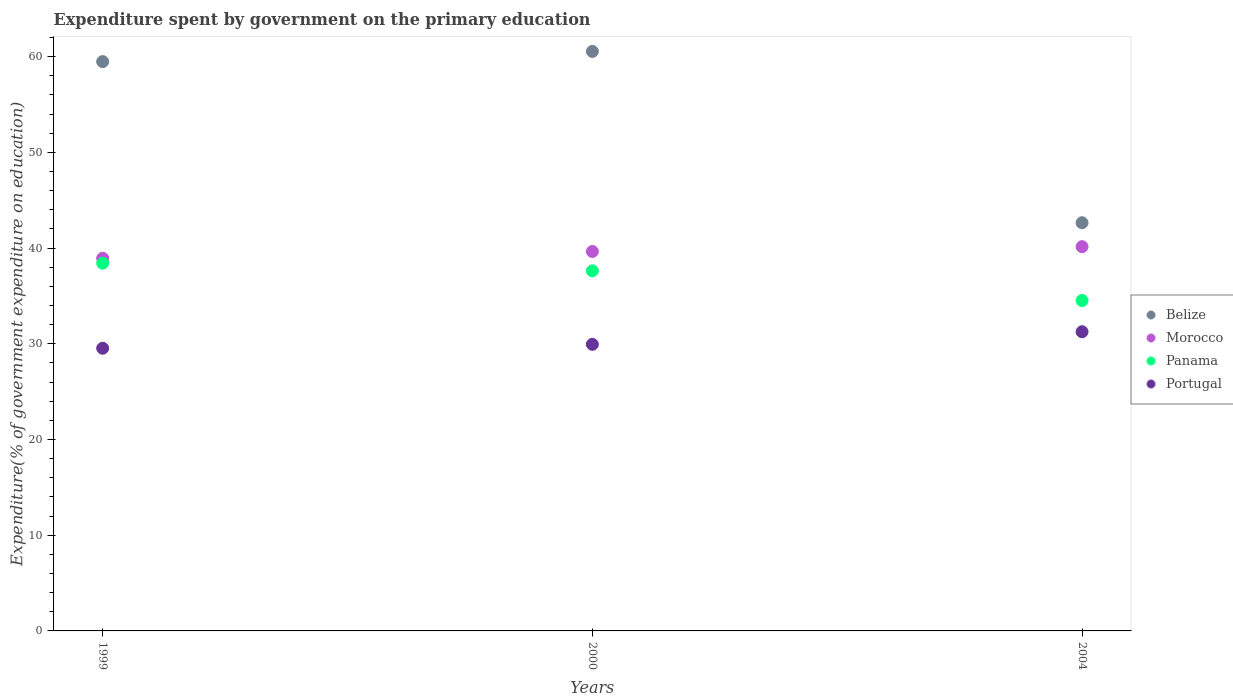How many different coloured dotlines are there?
Give a very brief answer. 4. Is the number of dotlines equal to the number of legend labels?
Make the answer very short. Yes. What is the expenditure spent by government on the primary education in Belize in 2004?
Keep it short and to the point. 42.65. Across all years, what is the maximum expenditure spent by government on the primary education in Portugal?
Give a very brief answer. 31.26. Across all years, what is the minimum expenditure spent by government on the primary education in Belize?
Offer a terse response. 42.65. What is the total expenditure spent by government on the primary education in Morocco in the graph?
Provide a succinct answer. 118.72. What is the difference between the expenditure spent by government on the primary education in Portugal in 1999 and that in 2004?
Your answer should be very brief. -1.72. What is the difference between the expenditure spent by government on the primary education in Panama in 1999 and the expenditure spent by government on the primary education in Belize in 2000?
Your answer should be very brief. -22.13. What is the average expenditure spent by government on the primary education in Panama per year?
Provide a short and direct response. 36.85. In the year 2000, what is the difference between the expenditure spent by government on the primary education in Morocco and expenditure spent by government on the primary education in Belize?
Your answer should be very brief. -20.9. In how many years, is the expenditure spent by government on the primary education in Portugal greater than 38 %?
Keep it short and to the point. 0. What is the ratio of the expenditure spent by government on the primary education in Belize in 1999 to that in 2000?
Keep it short and to the point. 0.98. Is the difference between the expenditure spent by government on the primary education in Morocco in 1999 and 2004 greater than the difference between the expenditure spent by government on the primary education in Belize in 1999 and 2004?
Give a very brief answer. No. What is the difference between the highest and the second highest expenditure spent by government on the primary education in Belize?
Your answer should be very brief. 1.07. What is the difference between the highest and the lowest expenditure spent by government on the primary education in Belize?
Your answer should be very brief. 17.9. In how many years, is the expenditure spent by government on the primary education in Panama greater than the average expenditure spent by government on the primary education in Panama taken over all years?
Make the answer very short. 2. Is the sum of the expenditure spent by government on the primary education in Belize in 1999 and 2004 greater than the maximum expenditure spent by government on the primary education in Morocco across all years?
Offer a very short reply. Yes. Is it the case that in every year, the sum of the expenditure spent by government on the primary education in Panama and expenditure spent by government on the primary education in Morocco  is greater than the sum of expenditure spent by government on the primary education in Belize and expenditure spent by government on the primary education in Portugal?
Keep it short and to the point. No. Is it the case that in every year, the sum of the expenditure spent by government on the primary education in Panama and expenditure spent by government on the primary education in Portugal  is greater than the expenditure spent by government on the primary education in Morocco?
Make the answer very short. Yes. Is the expenditure spent by government on the primary education in Panama strictly less than the expenditure spent by government on the primary education in Belize over the years?
Make the answer very short. Yes. How many years are there in the graph?
Your answer should be compact. 3. What is the difference between two consecutive major ticks on the Y-axis?
Offer a terse response. 10. Does the graph contain any zero values?
Your answer should be very brief. No. How are the legend labels stacked?
Make the answer very short. Vertical. What is the title of the graph?
Provide a succinct answer. Expenditure spent by government on the primary education. Does "Cameroon" appear as one of the legend labels in the graph?
Make the answer very short. No. What is the label or title of the X-axis?
Your answer should be very brief. Years. What is the label or title of the Y-axis?
Ensure brevity in your answer.  Expenditure(% of government expenditure on education). What is the Expenditure(% of government expenditure on education) of Belize in 1999?
Your answer should be compact. 59.48. What is the Expenditure(% of government expenditure on education) in Morocco in 1999?
Your answer should be compact. 38.93. What is the Expenditure(% of government expenditure on education) of Panama in 1999?
Provide a short and direct response. 38.42. What is the Expenditure(% of government expenditure on education) of Portugal in 1999?
Offer a very short reply. 29.53. What is the Expenditure(% of government expenditure on education) in Belize in 2000?
Give a very brief answer. 60.54. What is the Expenditure(% of government expenditure on education) of Morocco in 2000?
Keep it short and to the point. 39.64. What is the Expenditure(% of government expenditure on education) in Panama in 2000?
Provide a short and direct response. 37.62. What is the Expenditure(% of government expenditure on education) in Portugal in 2000?
Offer a very short reply. 29.94. What is the Expenditure(% of government expenditure on education) in Belize in 2004?
Your answer should be compact. 42.65. What is the Expenditure(% of government expenditure on education) in Morocco in 2004?
Offer a terse response. 40.15. What is the Expenditure(% of government expenditure on education) of Panama in 2004?
Provide a succinct answer. 34.52. What is the Expenditure(% of government expenditure on education) in Portugal in 2004?
Ensure brevity in your answer.  31.26. Across all years, what is the maximum Expenditure(% of government expenditure on education) in Belize?
Your answer should be compact. 60.54. Across all years, what is the maximum Expenditure(% of government expenditure on education) in Morocco?
Your answer should be very brief. 40.15. Across all years, what is the maximum Expenditure(% of government expenditure on education) in Panama?
Give a very brief answer. 38.42. Across all years, what is the maximum Expenditure(% of government expenditure on education) of Portugal?
Your answer should be very brief. 31.26. Across all years, what is the minimum Expenditure(% of government expenditure on education) of Belize?
Your response must be concise. 42.65. Across all years, what is the minimum Expenditure(% of government expenditure on education) in Morocco?
Give a very brief answer. 38.93. Across all years, what is the minimum Expenditure(% of government expenditure on education) in Panama?
Offer a very short reply. 34.52. Across all years, what is the minimum Expenditure(% of government expenditure on education) in Portugal?
Offer a very short reply. 29.53. What is the total Expenditure(% of government expenditure on education) in Belize in the graph?
Give a very brief answer. 162.67. What is the total Expenditure(% of government expenditure on education) of Morocco in the graph?
Your response must be concise. 118.72. What is the total Expenditure(% of government expenditure on education) of Panama in the graph?
Provide a succinct answer. 110.56. What is the total Expenditure(% of government expenditure on education) of Portugal in the graph?
Your answer should be compact. 90.73. What is the difference between the Expenditure(% of government expenditure on education) of Belize in 1999 and that in 2000?
Your response must be concise. -1.07. What is the difference between the Expenditure(% of government expenditure on education) in Morocco in 1999 and that in 2000?
Offer a very short reply. -0.71. What is the difference between the Expenditure(% of government expenditure on education) of Panama in 1999 and that in 2000?
Offer a terse response. 0.8. What is the difference between the Expenditure(% of government expenditure on education) in Portugal in 1999 and that in 2000?
Offer a terse response. -0.41. What is the difference between the Expenditure(% of government expenditure on education) in Belize in 1999 and that in 2004?
Your response must be concise. 16.83. What is the difference between the Expenditure(% of government expenditure on education) of Morocco in 1999 and that in 2004?
Your answer should be compact. -1.21. What is the difference between the Expenditure(% of government expenditure on education) in Panama in 1999 and that in 2004?
Make the answer very short. 3.9. What is the difference between the Expenditure(% of government expenditure on education) in Portugal in 1999 and that in 2004?
Offer a terse response. -1.72. What is the difference between the Expenditure(% of government expenditure on education) in Belize in 2000 and that in 2004?
Keep it short and to the point. 17.9. What is the difference between the Expenditure(% of government expenditure on education) of Morocco in 2000 and that in 2004?
Your answer should be very brief. -0.5. What is the difference between the Expenditure(% of government expenditure on education) of Panama in 2000 and that in 2004?
Provide a succinct answer. 3.1. What is the difference between the Expenditure(% of government expenditure on education) of Portugal in 2000 and that in 2004?
Offer a very short reply. -1.31. What is the difference between the Expenditure(% of government expenditure on education) in Belize in 1999 and the Expenditure(% of government expenditure on education) in Morocco in 2000?
Make the answer very short. 19.84. What is the difference between the Expenditure(% of government expenditure on education) of Belize in 1999 and the Expenditure(% of government expenditure on education) of Panama in 2000?
Your response must be concise. 21.86. What is the difference between the Expenditure(% of government expenditure on education) in Belize in 1999 and the Expenditure(% of government expenditure on education) in Portugal in 2000?
Provide a succinct answer. 29.54. What is the difference between the Expenditure(% of government expenditure on education) of Morocco in 1999 and the Expenditure(% of government expenditure on education) of Panama in 2000?
Offer a very short reply. 1.31. What is the difference between the Expenditure(% of government expenditure on education) of Morocco in 1999 and the Expenditure(% of government expenditure on education) of Portugal in 2000?
Offer a terse response. 8.99. What is the difference between the Expenditure(% of government expenditure on education) of Panama in 1999 and the Expenditure(% of government expenditure on education) of Portugal in 2000?
Offer a terse response. 8.48. What is the difference between the Expenditure(% of government expenditure on education) of Belize in 1999 and the Expenditure(% of government expenditure on education) of Morocco in 2004?
Keep it short and to the point. 19.33. What is the difference between the Expenditure(% of government expenditure on education) of Belize in 1999 and the Expenditure(% of government expenditure on education) of Panama in 2004?
Your response must be concise. 24.96. What is the difference between the Expenditure(% of government expenditure on education) in Belize in 1999 and the Expenditure(% of government expenditure on education) in Portugal in 2004?
Provide a short and direct response. 28.22. What is the difference between the Expenditure(% of government expenditure on education) of Morocco in 1999 and the Expenditure(% of government expenditure on education) of Panama in 2004?
Provide a succinct answer. 4.41. What is the difference between the Expenditure(% of government expenditure on education) in Morocco in 1999 and the Expenditure(% of government expenditure on education) in Portugal in 2004?
Provide a succinct answer. 7.68. What is the difference between the Expenditure(% of government expenditure on education) in Panama in 1999 and the Expenditure(% of government expenditure on education) in Portugal in 2004?
Ensure brevity in your answer.  7.16. What is the difference between the Expenditure(% of government expenditure on education) of Belize in 2000 and the Expenditure(% of government expenditure on education) of Morocco in 2004?
Provide a succinct answer. 20.4. What is the difference between the Expenditure(% of government expenditure on education) in Belize in 2000 and the Expenditure(% of government expenditure on education) in Panama in 2004?
Give a very brief answer. 26.03. What is the difference between the Expenditure(% of government expenditure on education) of Belize in 2000 and the Expenditure(% of government expenditure on education) of Portugal in 2004?
Keep it short and to the point. 29.29. What is the difference between the Expenditure(% of government expenditure on education) in Morocco in 2000 and the Expenditure(% of government expenditure on education) in Panama in 2004?
Your answer should be very brief. 5.12. What is the difference between the Expenditure(% of government expenditure on education) of Morocco in 2000 and the Expenditure(% of government expenditure on education) of Portugal in 2004?
Offer a terse response. 8.39. What is the difference between the Expenditure(% of government expenditure on education) of Panama in 2000 and the Expenditure(% of government expenditure on education) of Portugal in 2004?
Ensure brevity in your answer.  6.36. What is the average Expenditure(% of government expenditure on education) in Belize per year?
Give a very brief answer. 54.22. What is the average Expenditure(% of government expenditure on education) of Morocco per year?
Offer a terse response. 39.57. What is the average Expenditure(% of government expenditure on education) in Panama per year?
Your response must be concise. 36.85. What is the average Expenditure(% of government expenditure on education) of Portugal per year?
Provide a short and direct response. 30.24. In the year 1999, what is the difference between the Expenditure(% of government expenditure on education) in Belize and Expenditure(% of government expenditure on education) in Morocco?
Your response must be concise. 20.55. In the year 1999, what is the difference between the Expenditure(% of government expenditure on education) of Belize and Expenditure(% of government expenditure on education) of Panama?
Ensure brevity in your answer.  21.06. In the year 1999, what is the difference between the Expenditure(% of government expenditure on education) in Belize and Expenditure(% of government expenditure on education) in Portugal?
Your answer should be compact. 29.95. In the year 1999, what is the difference between the Expenditure(% of government expenditure on education) in Morocco and Expenditure(% of government expenditure on education) in Panama?
Make the answer very short. 0.51. In the year 1999, what is the difference between the Expenditure(% of government expenditure on education) of Morocco and Expenditure(% of government expenditure on education) of Portugal?
Your answer should be compact. 9.4. In the year 1999, what is the difference between the Expenditure(% of government expenditure on education) of Panama and Expenditure(% of government expenditure on education) of Portugal?
Provide a short and direct response. 8.89. In the year 2000, what is the difference between the Expenditure(% of government expenditure on education) in Belize and Expenditure(% of government expenditure on education) in Morocco?
Your answer should be compact. 20.9. In the year 2000, what is the difference between the Expenditure(% of government expenditure on education) of Belize and Expenditure(% of government expenditure on education) of Panama?
Keep it short and to the point. 22.92. In the year 2000, what is the difference between the Expenditure(% of government expenditure on education) of Belize and Expenditure(% of government expenditure on education) of Portugal?
Provide a succinct answer. 30.6. In the year 2000, what is the difference between the Expenditure(% of government expenditure on education) in Morocco and Expenditure(% of government expenditure on education) in Panama?
Keep it short and to the point. 2.02. In the year 2000, what is the difference between the Expenditure(% of government expenditure on education) of Morocco and Expenditure(% of government expenditure on education) of Portugal?
Offer a very short reply. 9.7. In the year 2000, what is the difference between the Expenditure(% of government expenditure on education) of Panama and Expenditure(% of government expenditure on education) of Portugal?
Keep it short and to the point. 7.68. In the year 2004, what is the difference between the Expenditure(% of government expenditure on education) in Belize and Expenditure(% of government expenditure on education) in Morocco?
Give a very brief answer. 2.5. In the year 2004, what is the difference between the Expenditure(% of government expenditure on education) in Belize and Expenditure(% of government expenditure on education) in Panama?
Ensure brevity in your answer.  8.13. In the year 2004, what is the difference between the Expenditure(% of government expenditure on education) in Belize and Expenditure(% of government expenditure on education) in Portugal?
Provide a succinct answer. 11.39. In the year 2004, what is the difference between the Expenditure(% of government expenditure on education) in Morocco and Expenditure(% of government expenditure on education) in Panama?
Offer a very short reply. 5.63. In the year 2004, what is the difference between the Expenditure(% of government expenditure on education) in Morocco and Expenditure(% of government expenditure on education) in Portugal?
Your response must be concise. 8.89. In the year 2004, what is the difference between the Expenditure(% of government expenditure on education) of Panama and Expenditure(% of government expenditure on education) of Portugal?
Make the answer very short. 3.26. What is the ratio of the Expenditure(% of government expenditure on education) in Belize in 1999 to that in 2000?
Ensure brevity in your answer.  0.98. What is the ratio of the Expenditure(% of government expenditure on education) in Morocco in 1999 to that in 2000?
Your answer should be compact. 0.98. What is the ratio of the Expenditure(% of government expenditure on education) in Panama in 1999 to that in 2000?
Your response must be concise. 1.02. What is the ratio of the Expenditure(% of government expenditure on education) in Portugal in 1999 to that in 2000?
Offer a terse response. 0.99. What is the ratio of the Expenditure(% of government expenditure on education) in Belize in 1999 to that in 2004?
Offer a very short reply. 1.39. What is the ratio of the Expenditure(% of government expenditure on education) of Morocco in 1999 to that in 2004?
Make the answer very short. 0.97. What is the ratio of the Expenditure(% of government expenditure on education) in Panama in 1999 to that in 2004?
Keep it short and to the point. 1.11. What is the ratio of the Expenditure(% of government expenditure on education) in Portugal in 1999 to that in 2004?
Provide a short and direct response. 0.94. What is the ratio of the Expenditure(% of government expenditure on education) of Belize in 2000 to that in 2004?
Your response must be concise. 1.42. What is the ratio of the Expenditure(% of government expenditure on education) in Morocco in 2000 to that in 2004?
Your answer should be compact. 0.99. What is the ratio of the Expenditure(% of government expenditure on education) in Panama in 2000 to that in 2004?
Offer a terse response. 1.09. What is the ratio of the Expenditure(% of government expenditure on education) in Portugal in 2000 to that in 2004?
Provide a succinct answer. 0.96. What is the difference between the highest and the second highest Expenditure(% of government expenditure on education) in Belize?
Ensure brevity in your answer.  1.07. What is the difference between the highest and the second highest Expenditure(% of government expenditure on education) in Morocco?
Your answer should be very brief. 0.5. What is the difference between the highest and the second highest Expenditure(% of government expenditure on education) in Panama?
Your answer should be compact. 0.8. What is the difference between the highest and the second highest Expenditure(% of government expenditure on education) in Portugal?
Provide a short and direct response. 1.31. What is the difference between the highest and the lowest Expenditure(% of government expenditure on education) of Belize?
Keep it short and to the point. 17.9. What is the difference between the highest and the lowest Expenditure(% of government expenditure on education) of Morocco?
Keep it short and to the point. 1.21. What is the difference between the highest and the lowest Expenditure(% of government expenditure on education) in Panama?
Keep it short and to the point. 3.9. What is the difference between the highest and the lowest Expenditure(% of government expenditure on education) in Portugal?
Provide a short and direct response. 1.72. 